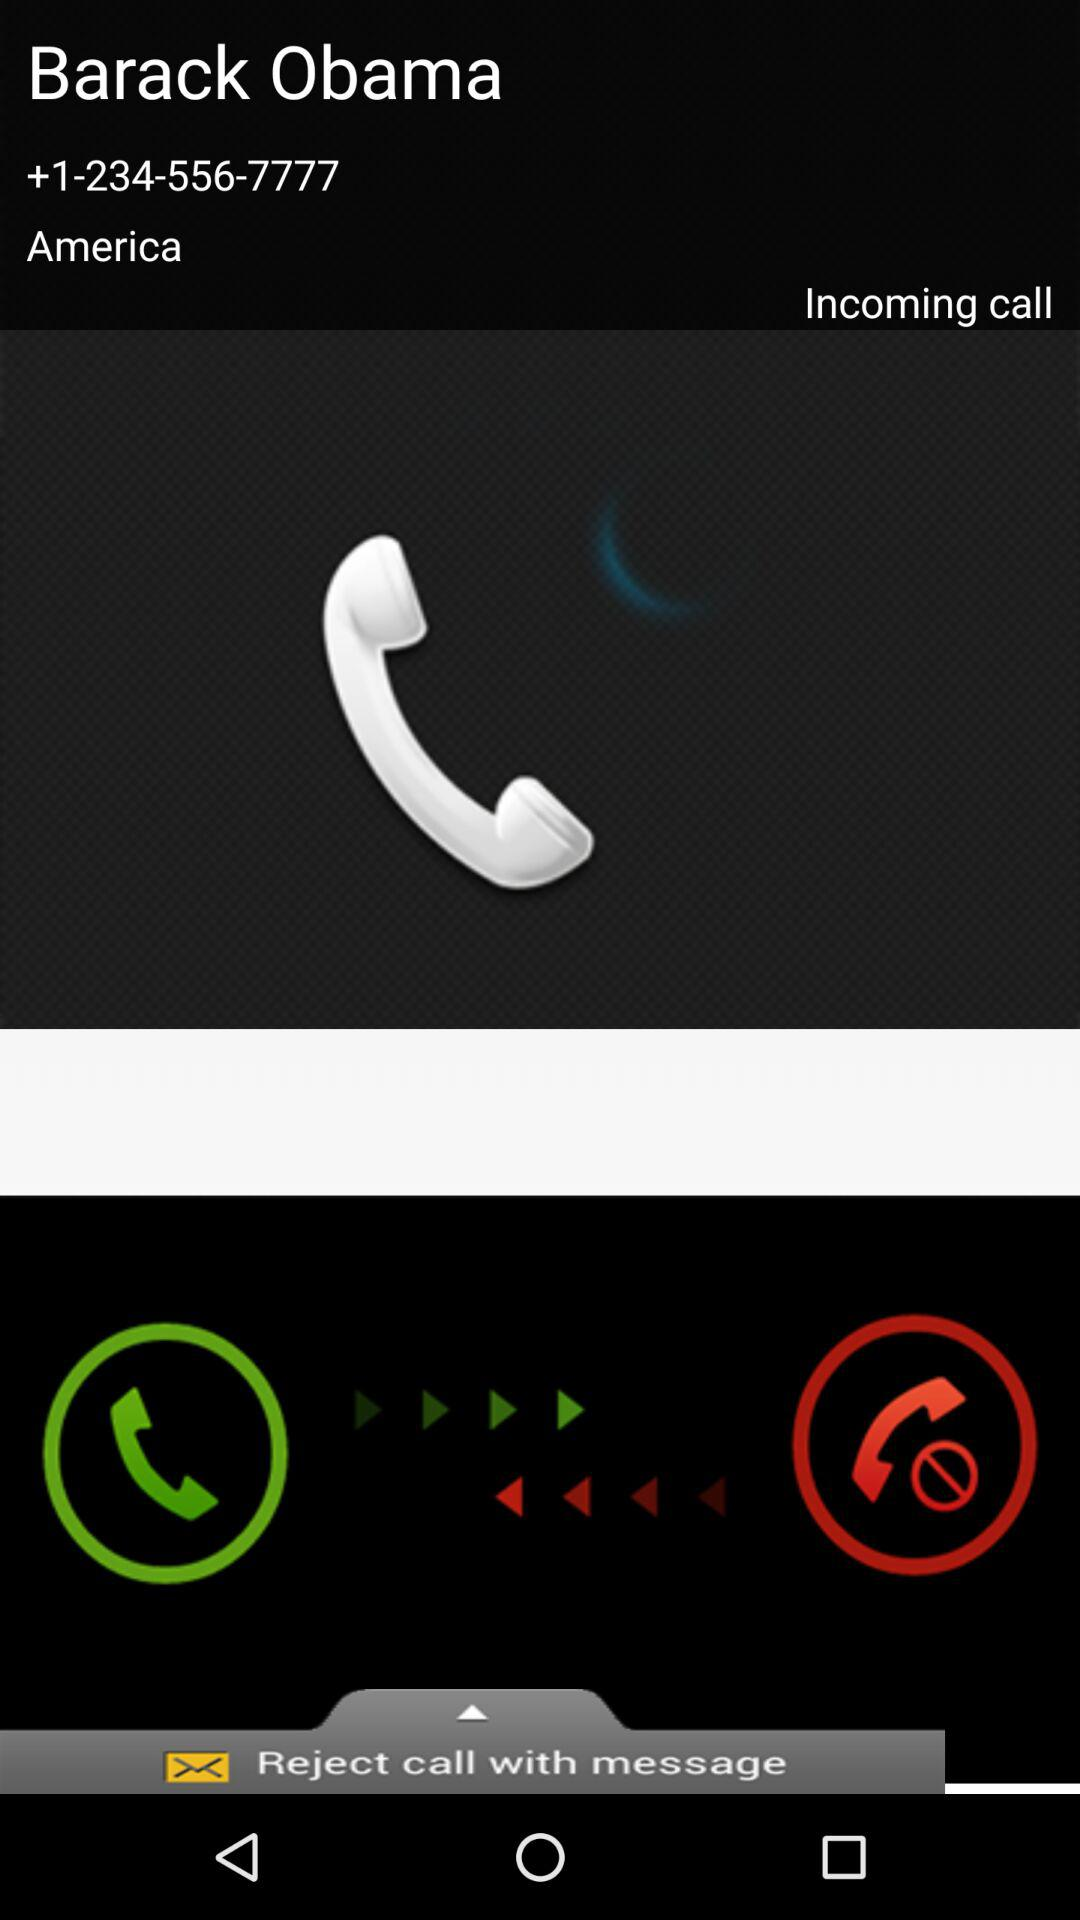What is the name of the caller? The name of the caller is Barack Obama. 